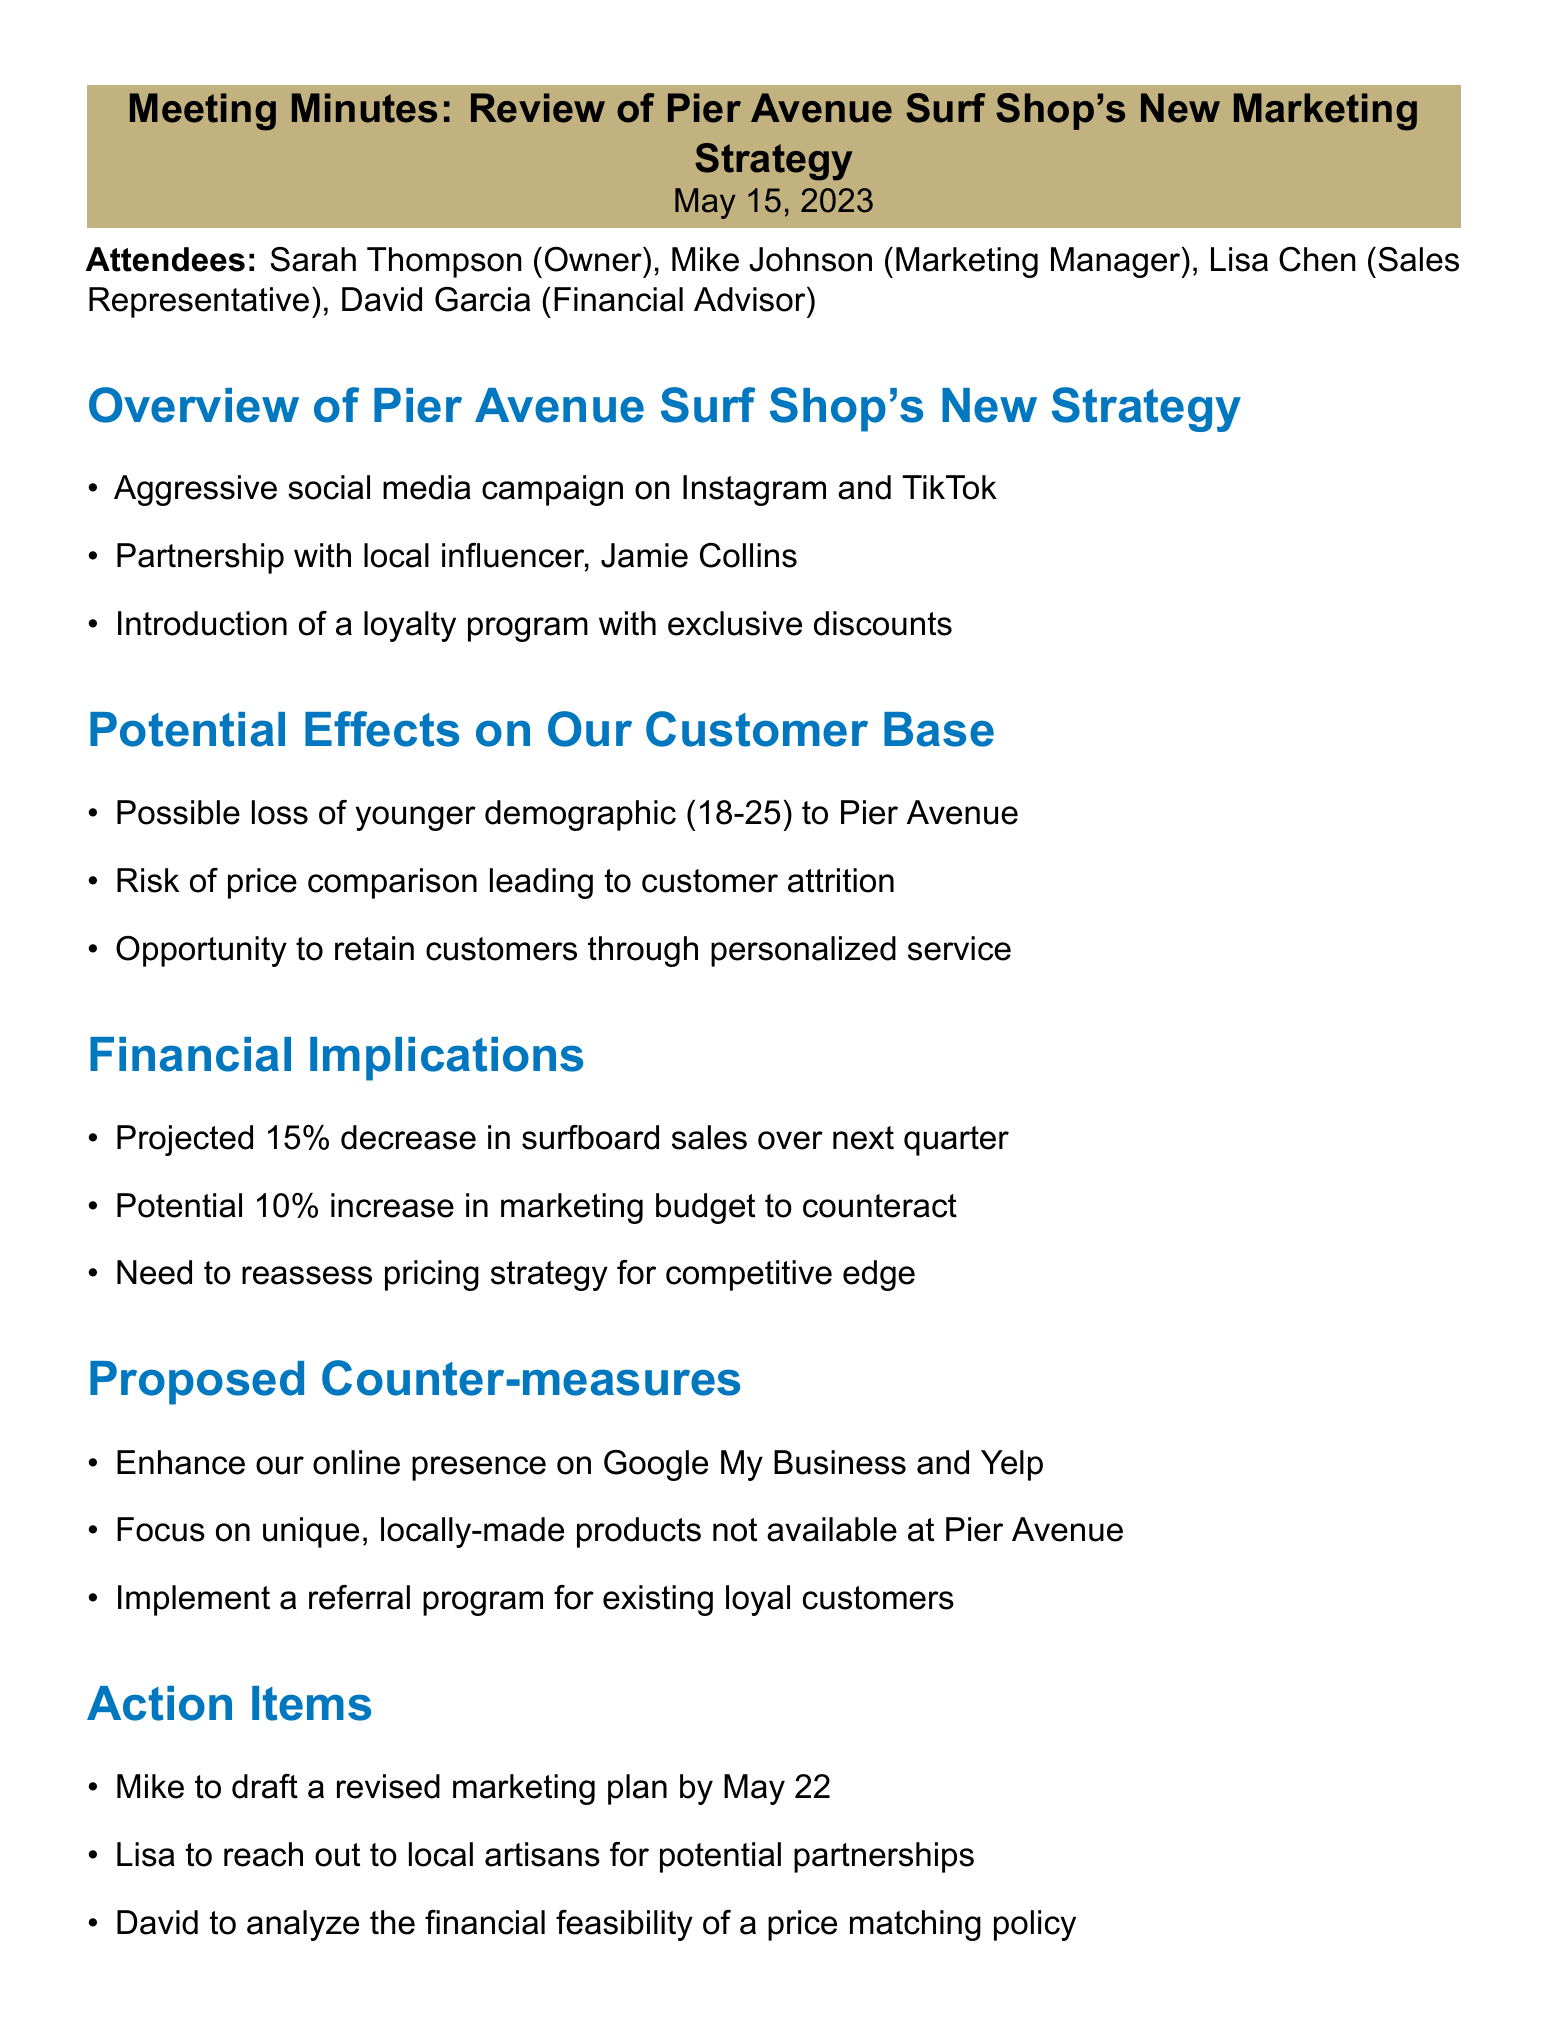What is the meeting title? The meeting title is stated at the beginning of the document.
Answer: Review of Pier Avenue Surf Shop's New Marketing Strategy Who is the marketing manager? The marketing manager's name is listed under the attendees section.
Answer: Mike Johnson What date was the meeting held? The date is clearly mentioned at the top of the document.
Answer: May 15, 2023 What is projected to decrease by 15%? This is found in the financial implications section of the document.
Answer: Surfboard sales What is one of the proposed counter-measures? This is a specific point mentioned under the proposed counter-measures section.
Answer: Enhance our online presence on Google My Business and Yelp What demographic is at risk of being lost? This information is contained within the potential effects section.
Answer: Younger demographic (18-25) What is the suggested increase in the marketing budget? The proposed financial measure is detailed in the financial implications section.
Answer: 10% What did the owner emphasize regarding change? This is reflected in the owner's comments section of the document.
Answer: Change grudgingly and minimally What is one action item for Lisa? The action items section lists specific responsibilities assigned to attendees.
Answer: Reach out to local artisans for potential partnerships 